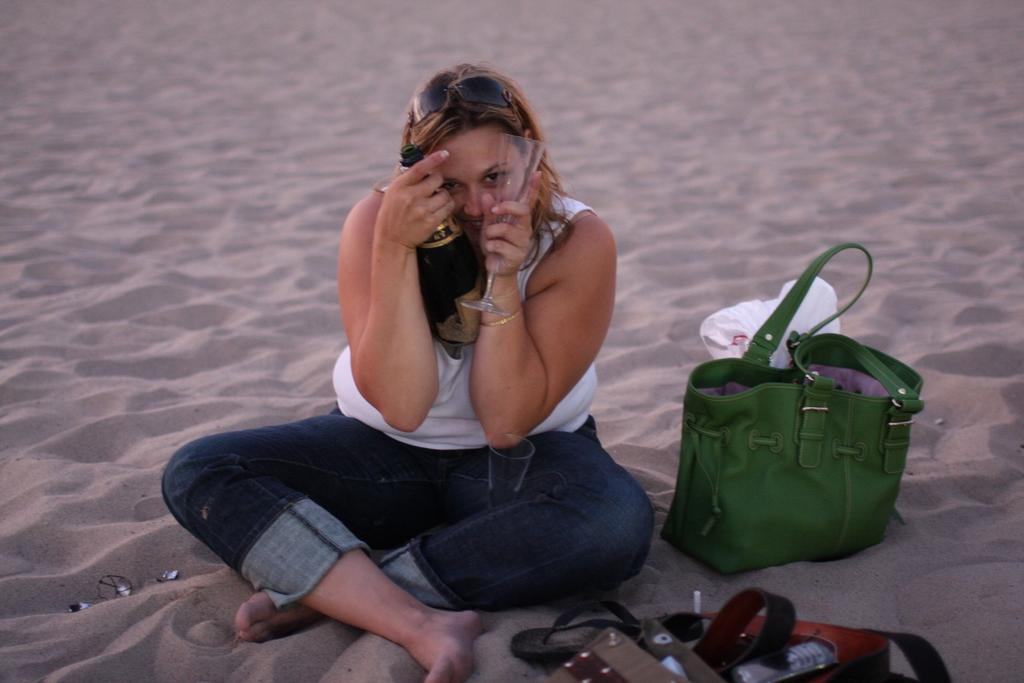What is the person sitting on in the image? The person is sitting on sand in the image. What is the person holding in their hand? The person is holding a glass and a wine bottle in their hand. What can be seen in the background of the image? There is a bag and a belt in the background of the image. How many eggs are visible in the image? There are no eggs visible in the image. What type of credit is the person using to purchase the wine bottle? There is no indication of credit being used in the image; the person is simply holding a wine bottle. 